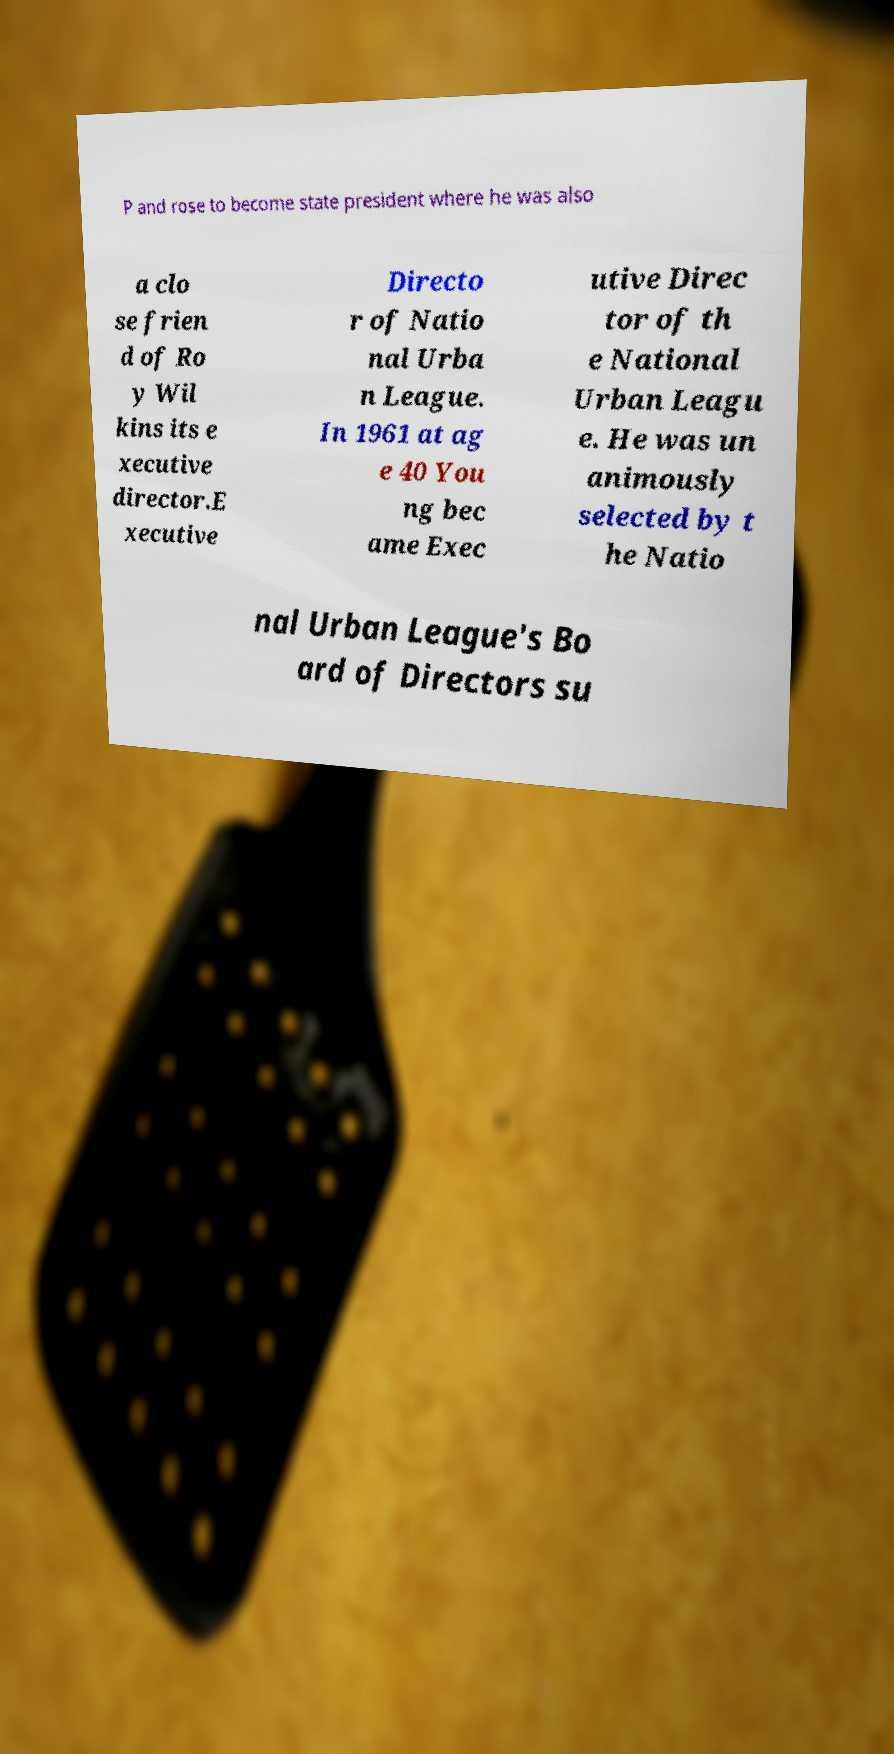What messages or text are displayed in this image? I need them in a readable, typed format. P and rose to become state president where he was also a clo se frien d of Ro y Wil kins its e xecutive director.E xecutive Directo r of Natio nal Urba n League. In 1961 at ag e 40 You ng bec ame Exec utive Direc tor of th e National Urban Leagu e. He was un animously selected by t he Natio nal Urban League's Bo ard of Directors su 